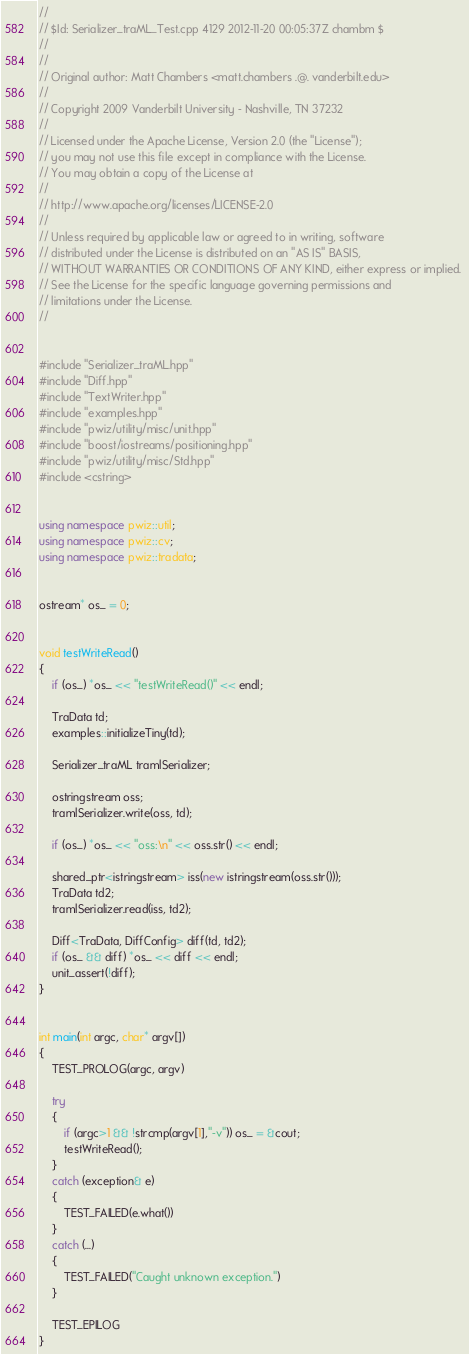<code> <loc_0><loc_0><loc_500><loc_500><_C++_>//
// $Id: Serializer_traML_Test.cpp 4129 2012-11-20 00:05:37Z chambm $
//
//
// Original author: Matt Chambers <matt.chambers .@. vanderbilt.edu>
//
// Copyright 2009 Vanderbilt University - Nashville, TN 37232
//
// Licensed under the Apache License, Version 2.0 (the "License"); 
// you may not use this file except in compliance with the License. 
// You may obtain a copy of the License at 
//
// http://www.apache.org/licenses/LICENSE-2.0
//
// Unless required by applicable law or agreed to in writing, software 
// distributed under the License is distributed on an "AS IS" BASIS, 
// WITHOUT WARRANTIES OR CONDITIONS OF ANY KIND, either express or implied. 
// See the License for the specific language governing permissions and 
// limitations under the License.
//


#include "Serializer_traML.hpp"
#include "Diff.hpp"
#include "TextWriter.hpp"
#include "examples.hpp"
#include "pwiz/utility/misc/unit.hpp"
#include "boost/iostreams/positioning.hpp"
#include "pwiz/utility/misc/Std.hpp"
#include <cstring>


using namespace pwiz::util;
using namespace pwiz::cv;
using namespace pwiz::tradata;


ostream* os_ = 0;


void testWriteRead()
{
    if (os_) *os_ << "testWriteRead()" << endl;

    TraData td;
    examples::initializeTiny(td);

    Serializer_traML tramlSerializer;

    ostringstream oss;
    tramlSerializer.write(oss, td);

    if (os_) *os_ << "oss:\n" << oss.str() << endl; 

    shared_ptr<istringstream> iss(new istringstream(oss.str()));
    TraData td2;
    tramlSerializer.read(iss, td2);

    Diff<TraData, DiffConfig> diff(td, td2);
    if (os_ && diff) *os_ << diff << endl; 
    unit_assert(!diff);
}


int main(int argc, char* argv[])
{
    TEST_PROLOG(argc, argv)

    try
    {
        if (argc>1 && !strcmp(argv[1],"-v")) os_ = &cout;
        testWriteRead();
    }
    catch (exception& e)
    {
        TEST_FAILED(e.what())
    }
    catch (...)
    {
        TEST_FAILED("Caught unknown exception.")
    }

    TEST_EPILOG
}
</code> 